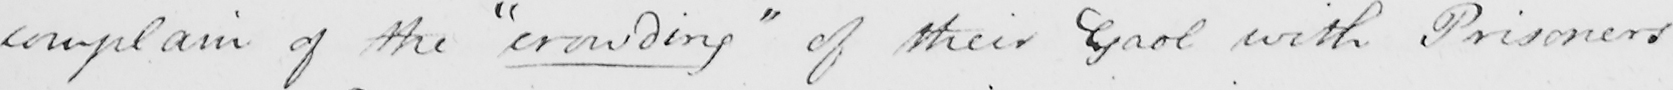Transcribe the text shown in this historical manuscript line. complain of the  " crowding "  of their Gaol with Prisoners 